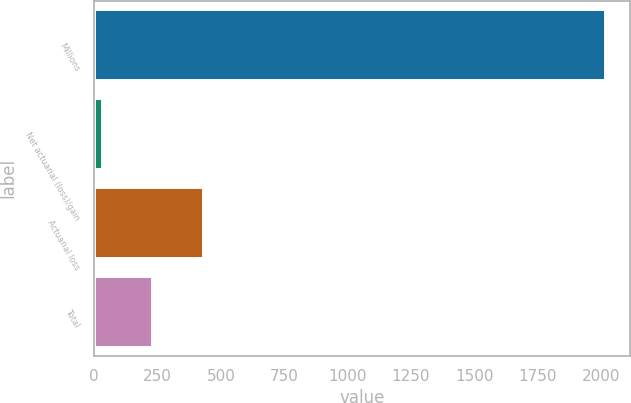Convert chart to OTSL. <chart><loc_0><loc_0><loc_500><loc_500><bar_chart><fcel>Millions<fcel>Net actuarial (loss)/gain<fcel>Actuarial loss<fcel>Total<nl><fcel>2015<fcel>31<fcel>427.8<fcel>229.4<nl></chart> 